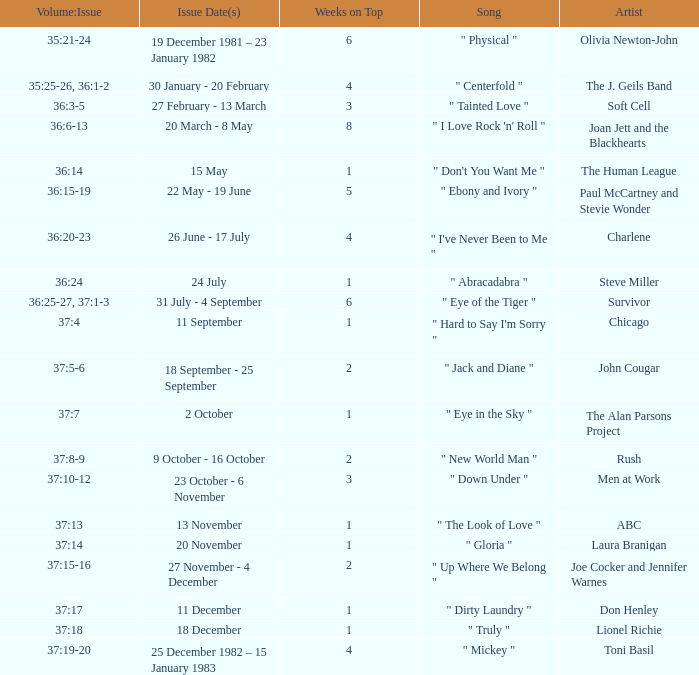Which Weeks on Top have an Issue Date(s) of 20 november? 1.0. 